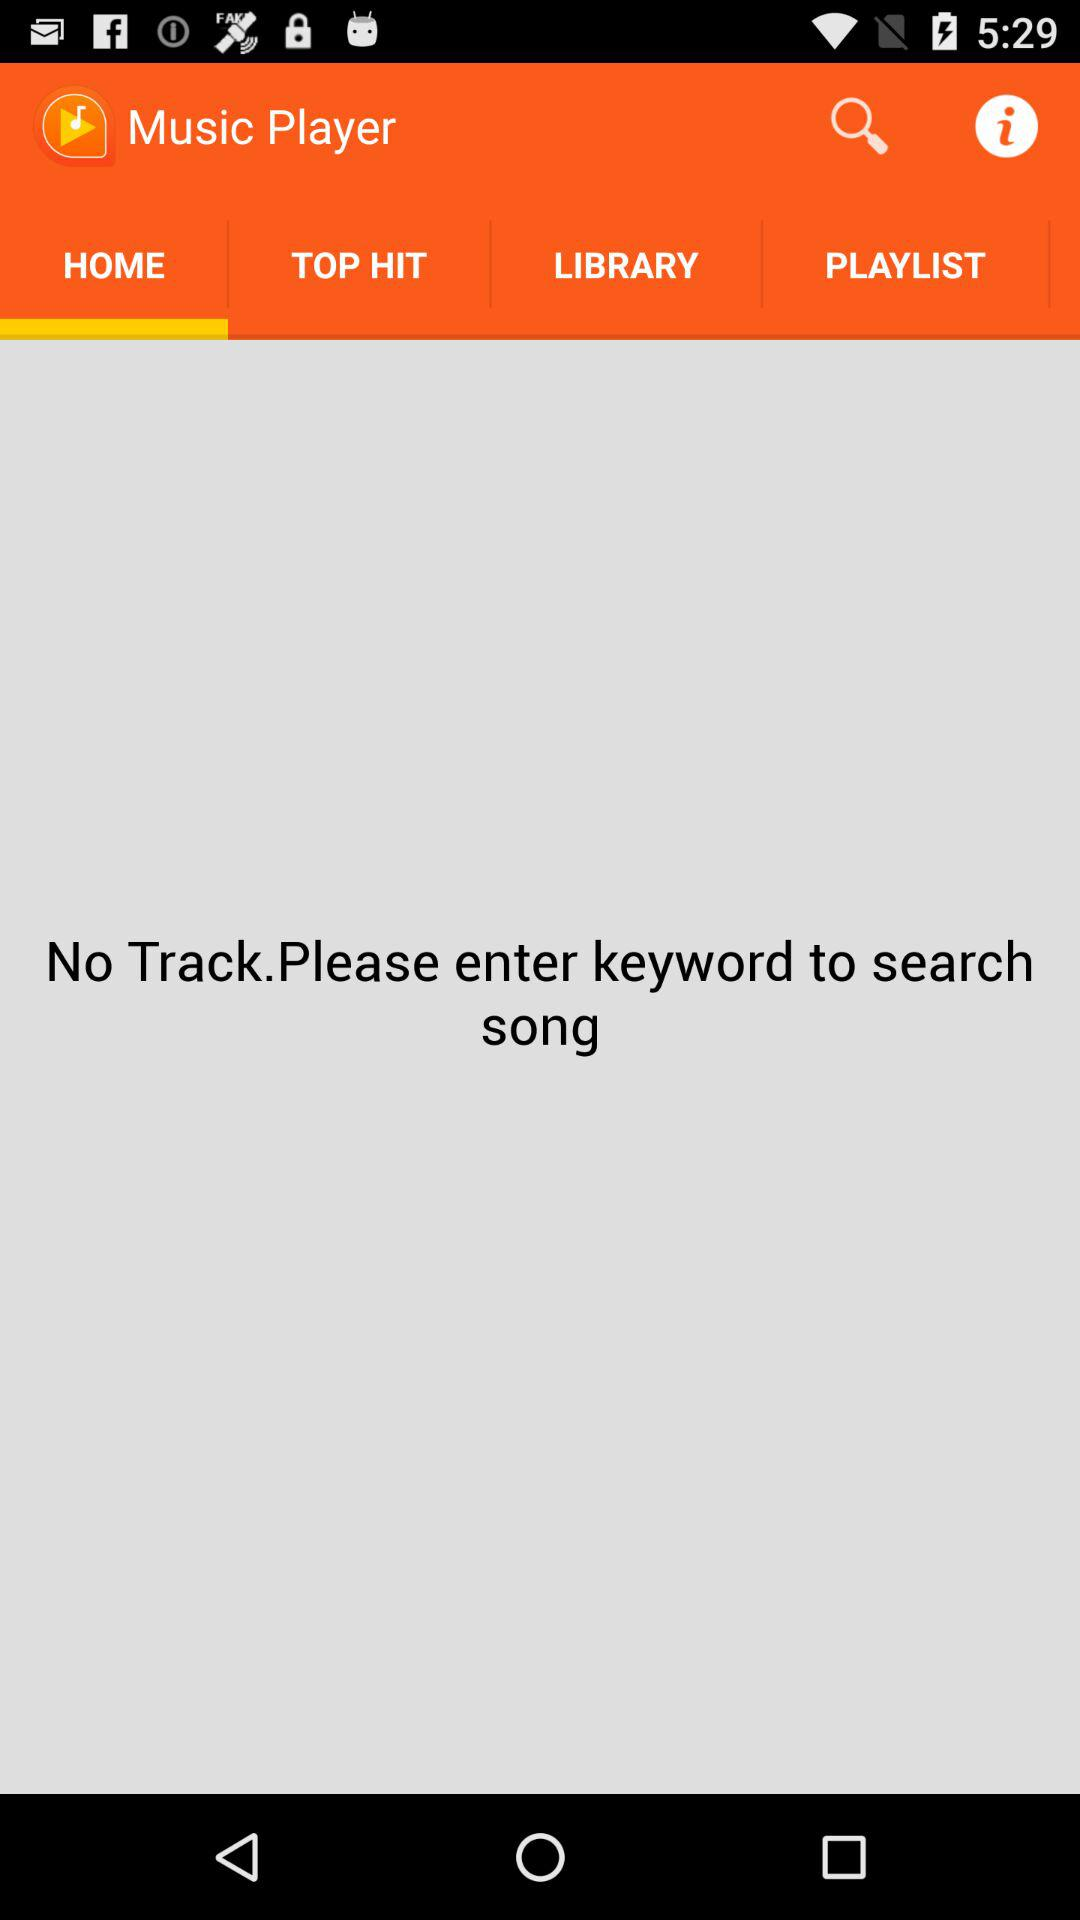Is there any track? No, there is no track. 